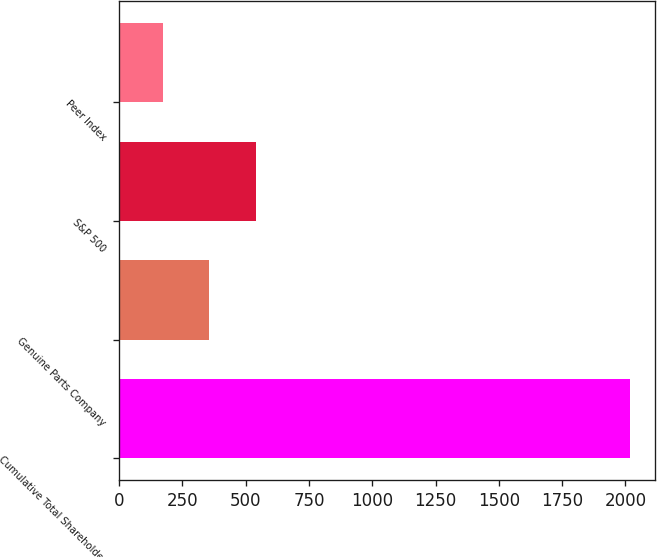Convert chart to OTSL. <chart><loc_0><loc_0><loc_500><loc_500><bar_chart><fcel>Cumulative Total Shareholder<fcel>Genuine Parts Company<fcel>S&P 500<fcel>Peer Index<nl><fcel>2016<fcel>356.18<fcel>540.6<fcel>171.76<nl></chart> 